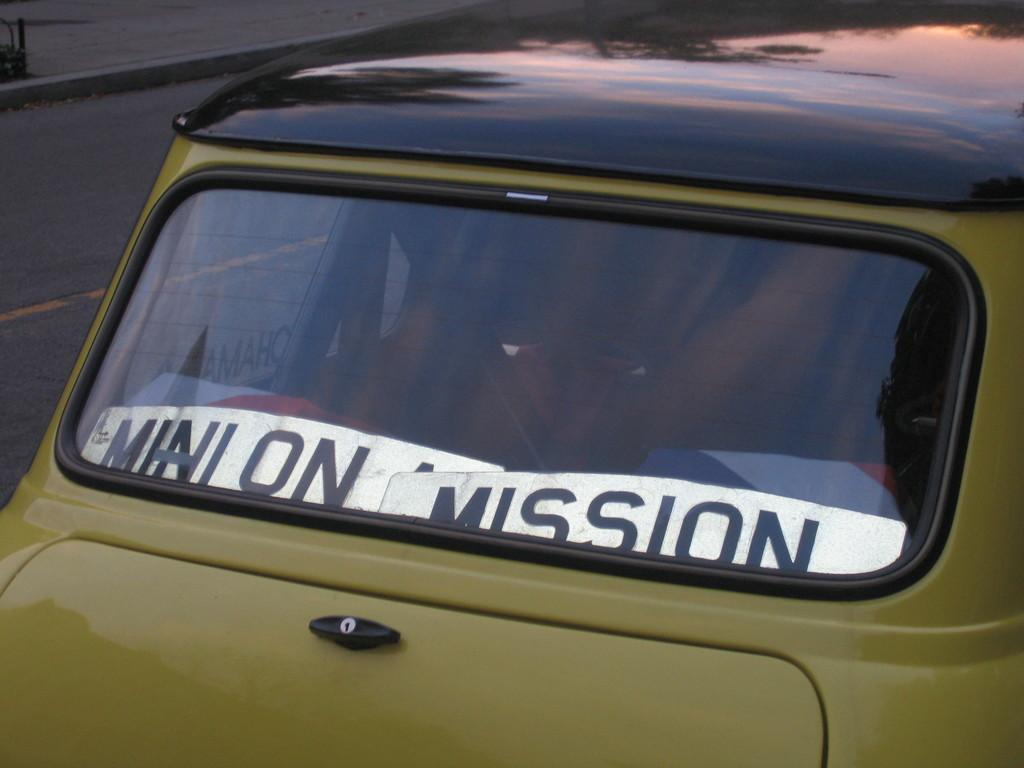What is the main subject of the image? There is a vehicle in the image. What can be seen on the left side of the image? There is a road on the left side of the image. What material is visible in the image? There is glass visible in the image. Are there any words or letters in the image? Yes, there is some text in the image. What type of corn is growing on the door in the image? There is no corn or door present in the image. 